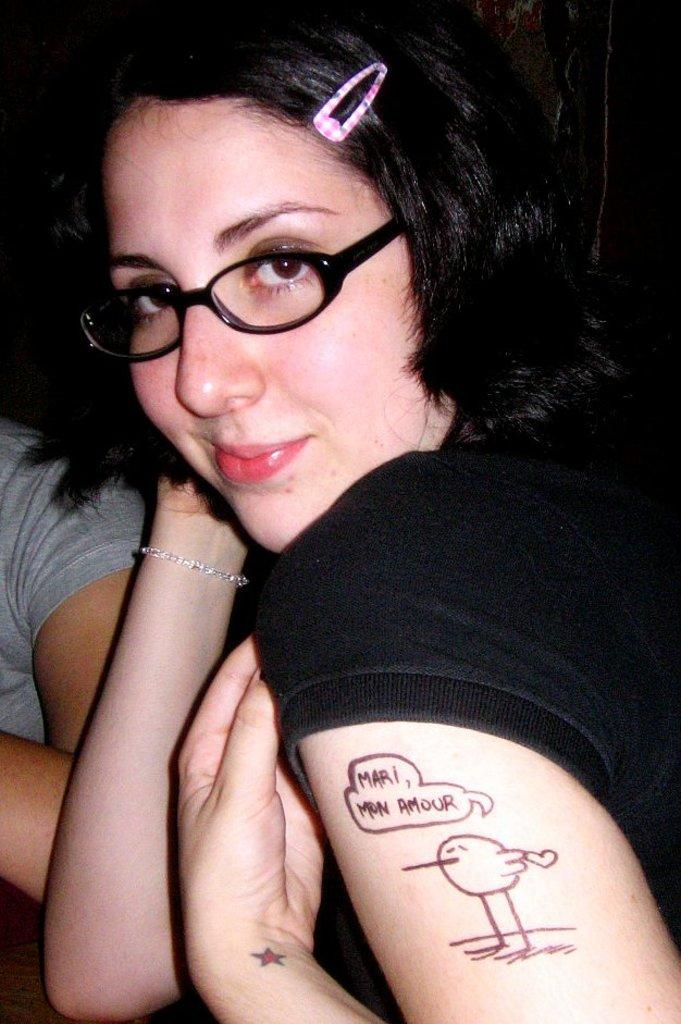Who is the main subject in the image? There is a woman in the image. What is the woman wearing? The woman is wearing spectacles. Can you describe any additional details about the woman? There is text on the woman's hand. Are there any other people in the image? Yes, there is another woman towards the left of the image. What is the color of the background in the image? The background of the image is dark. What type of dog can be seen playing with bells in the image? There is no dog or bells present in the image; it features two women and text on one of their hands. How many sons does the woman in the image have? There is no information about the woman's son(s) in the image. 